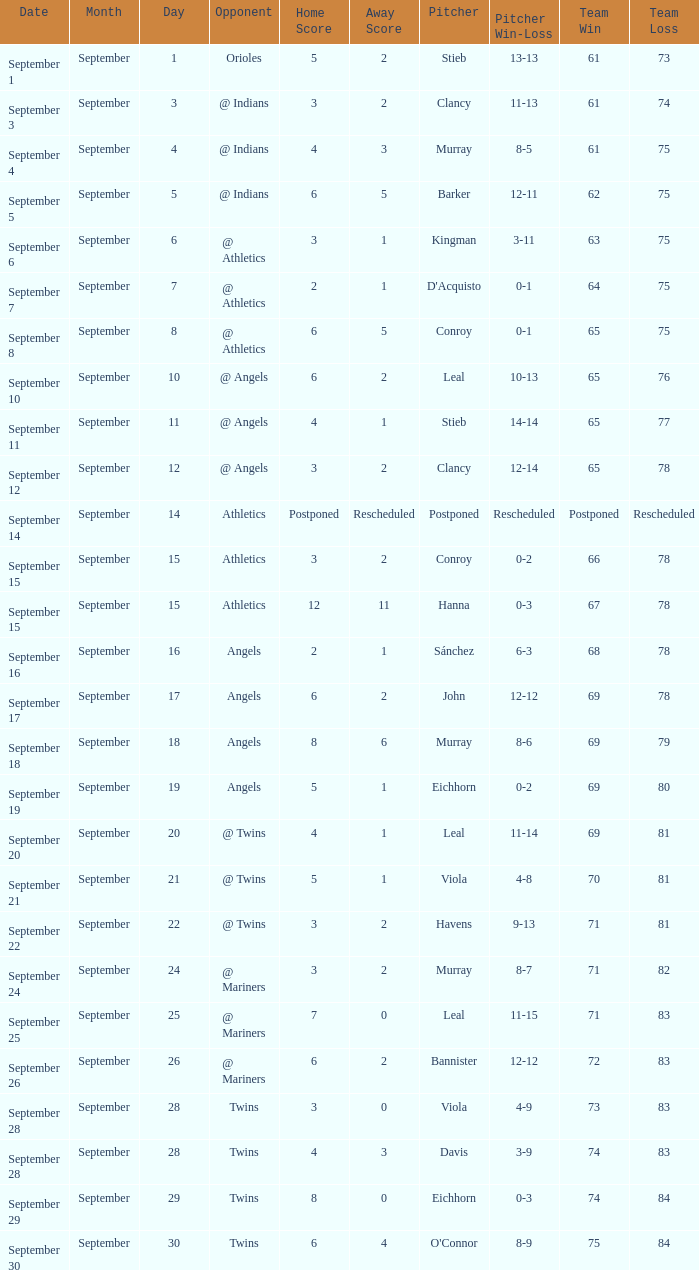What is the score that holds a record of 73-83? 3 - 0. 